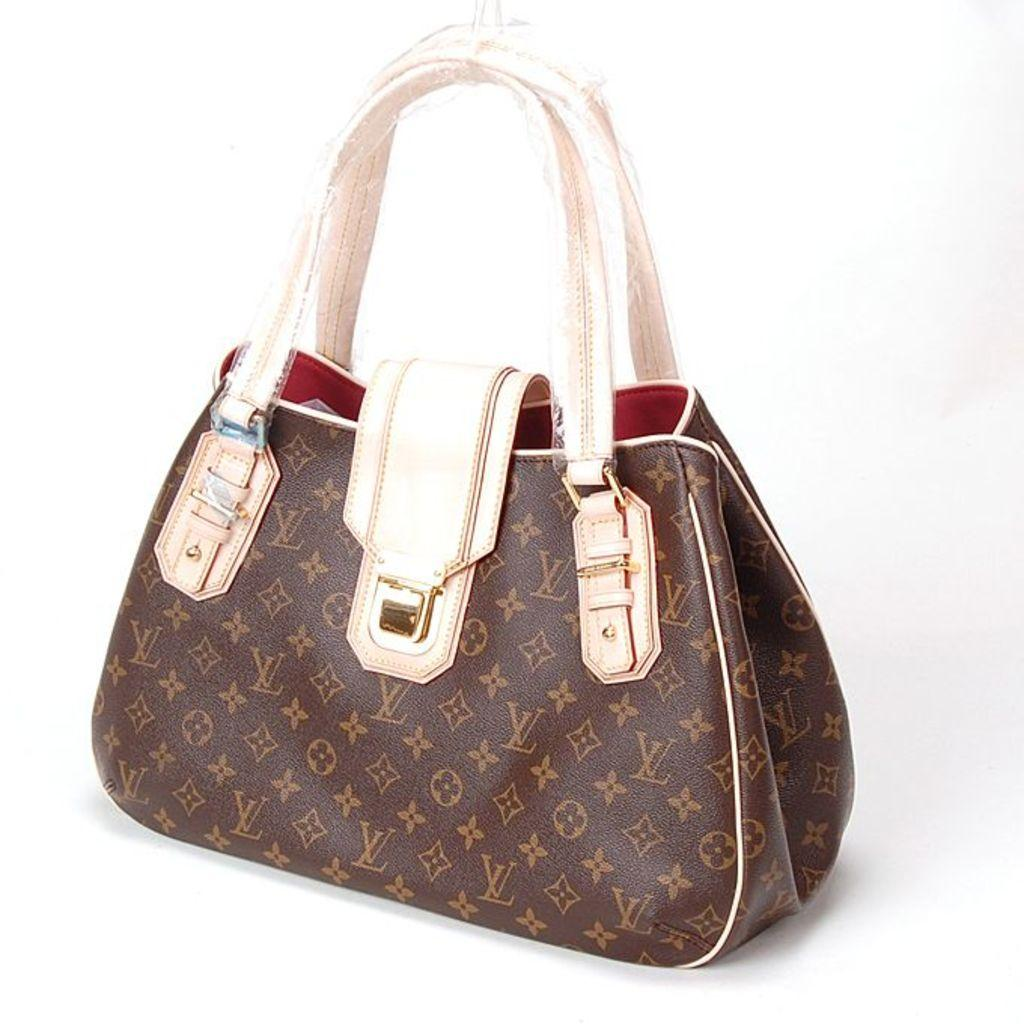What type of accessory is present in the image? There is a handbag in the image. What is the color of the handbag? The handbag is brown in color. What part of the handbag is white? The handles of the handbag are white. How can the handbag be opened? The handbag has a clutch for opening it. Is there a carriage being pulled by horses in the image? No, there is no carriage or horses present in the image; it features a handbag. Can you see a boat sailing in the background of the image? No, there is no boat or water visible in the image; it features a handbag on a surface. 